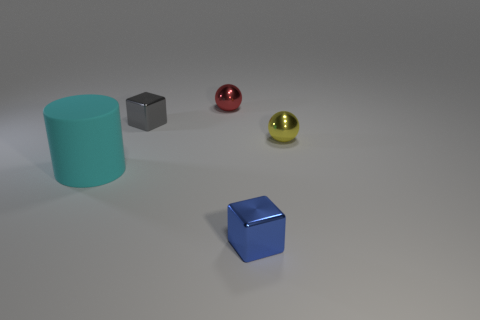Subtract all blue cubes. How many cubes are left? 1 Subtract all cylinders. How many objects are left? 4 Add 4 big yellow metal objects. How many objects exist? 9 Subtract 0 purple blocks. How many objects are left? 5 Subtract all yellow metal balls. Subtract all small blue blocks. How many objects are left? 3 Add 4 small metal things. How many small metal things are left? 8 Add 3 blue objects. How many blue objects exist? 4 